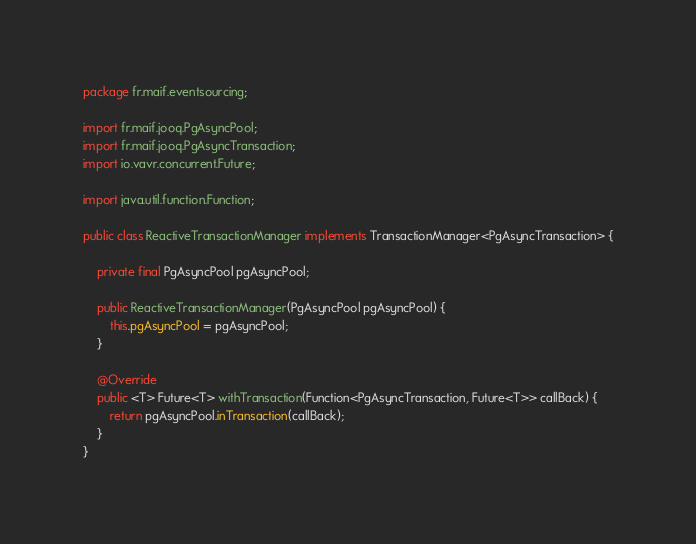<code> <loc_0><loc_0><loc_500><loc_500><_Java_>package fr.maif.eventsourcing;

import fr.maif.jooq.PgAsyncPool;
import fr.maif.jooq.PgAsyncTransaction;
import io.vavr.concurrent.Future;

import java.util.function.Function;

public class ReactiveTransactionManager implements TransactionManager<PgAsyncTransaction> {

    private final PgAsyncPool pgAsyncPool;

    public ReactiveTransactionManager(PgAsyncPool pgAsyncPool) {
        this.pgAsyncPool = pgAsyncPool;
    }

    @Override
    public <T> Future<T> withTransaction(Function<PgAsyncTransaction, Future<T>> callBack) {
        return pgAsyncPool.inTransaction(callBack);
    }
}
</code> 